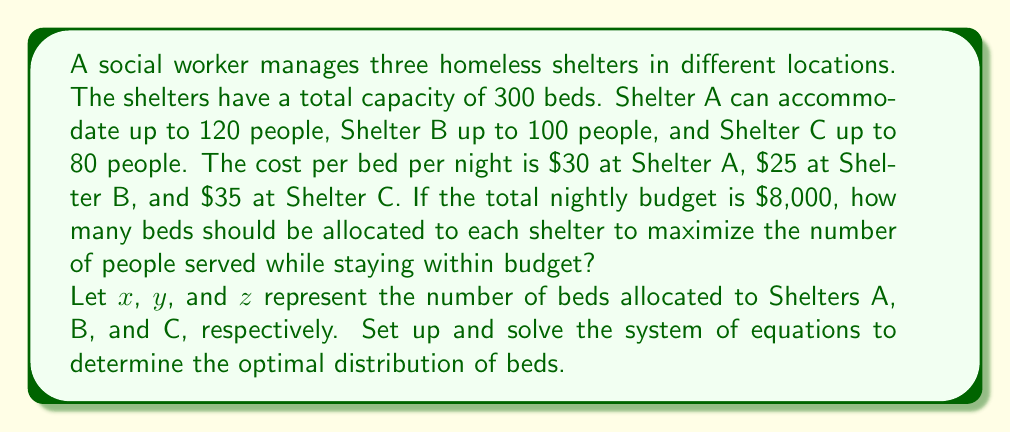Help me with this question. To solve this problem, we need to set up a system of equations based on the given constraints and then maximize the total number of beds within the budget.

Step 1: Set up the equations
1. Total capacity constraint: $x + y + z = 300$
2. Budget constraint: $30x + 25y + 35z = 8000$
3. Individual shelter constraints:
   $0 \leq x \leq 120$
   $0 \leq y \leq 100$
   $0 \leq z \leq 80$

Step 2: Maximize the number of beds
We want to maximize $x + y + z$ subject to the constraints above.

Step 3: Solve the system of equations
We can use the substitution method:
From equation 1: $z = 300 - x - y$

Substitute this into equation 2:
$30x + 25y + 35(300 - x - y) = 8000$
$30x + 25y + 10500 - 35x - 35y = 8000$
$-5x - 10y = -2500$
$x + 2y = 500$ (Equation 3)

Now we have two equations:
$x + y + z = 300$ (Equation 1)
$x + 2y = 500$ (Equation 3)

Subtracting Equation 1 from Equation 3:
$y - z = 200$

Step 4: Determine the optimal distribution
Given the cost per bed, we should prioritize filling Shelter B (lowest cost), then Shelter A, and finally Shelter C.

Shelter B: $y = 100$ (maximum capacity)
From $y - z = 200$, we get $z = -100$, which is not possible.
So, we set $z = 0$ (minimum capacity for Shelter C)

Then, $y - 0 = 200$, so $y = 200$, but this exceeds Shelter B's capacity.
We keep $y = 100$ (maximum for Shelter B)

From Equation 3: $x + 2(100) = 500$, so $x = 300$
But this exceeds Shelter A's capacity, so we set $x = 120$ (maximum for Shelter A)

Finally, from Equation 1: $120 + 100 + z = 300$, so $z = 80$

Step 5: Verify the budget constraint
$30(120) + 25(100) + 35(80) = 3600 + 2500 + 2800 = 8900$

This exceeds the budget, so we need to reduce the allocation to Shelter C.

$z = (8000 - 3600 - 2500) / 35 = 54.29$

Rounding down to stay within budget: $z = 54$

Therefore, the optimal distribution is:
Shelter A: 120 beds
Shelter B: 100 beds
Shelter C: 54 beds
Answer: Shelter A: 120 beds, Shelter B: 100 beds, Shelter C: 54 beds 